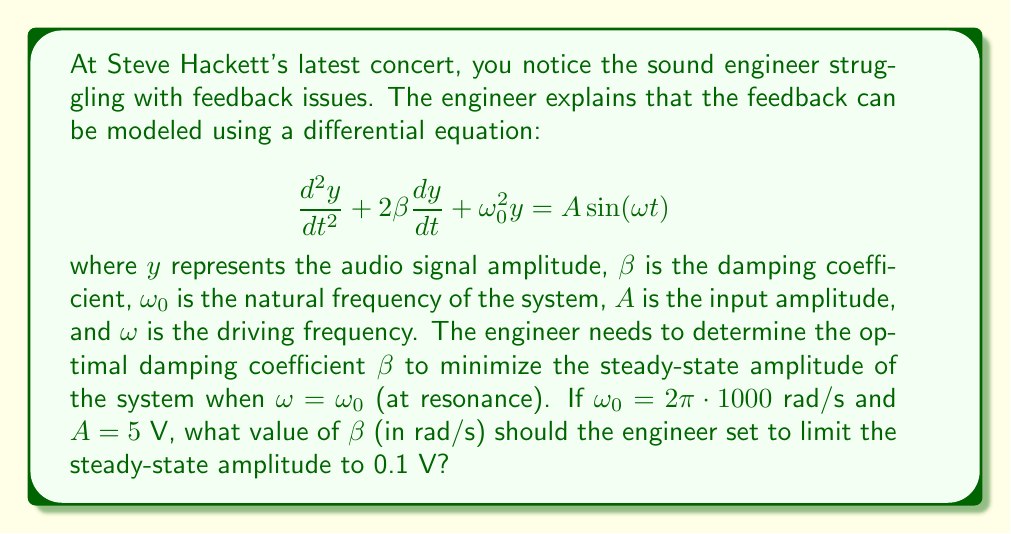Teach me how to tackle this problem. Let's approach this step-by-step:

1) The steady-state solution for a driven harmonic oscillator at resonance (when $\omega = \omega_0$) is given by:

   $$y(t) = \frac{A}{2\beta\omega_0}\sin(\omega_0 t - \frac{\pi}{2})$$

2) The amplitude of this steady-state solution is:

   $$y_{max} = \frac{A}{2\beta\omega_0}$$

3) We want to limit this amplitude to 0.1 V, so:

   $$0.1 = \frac{A}{2\beta\omega_0}$$

4) We're given that $A = 5$ V and $\omega_0 = 2\pi\cdot 1000$ rad/s. Let's substitute these values:

   $$0.1 = \frac{5}{2\beta(2\pi\cdot 1000)}$$

5) Now, let's solve for $\beta$:

   $$\beta = \frac{5}{2\cdot 0.1 \cdot 2\pi\cdot 1000}$$

6) Simplify:

   $$\beta = \frac{5}{400\pi} \approx 3979.49 \text{ rad/s}$$

Therefore, the engineer should set the damping coefficient $\beta$ to approximately 3979.49 rad/s to limit the steady-state amplitude to 0.1 V.
Answer: $\beta \approx 3979.49 \text{ rad/s}$ 